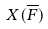Convert formula to latex. <formula><loc_0><loc_0><loc_500><loc_500>X ( \overline { F } )</formula> 